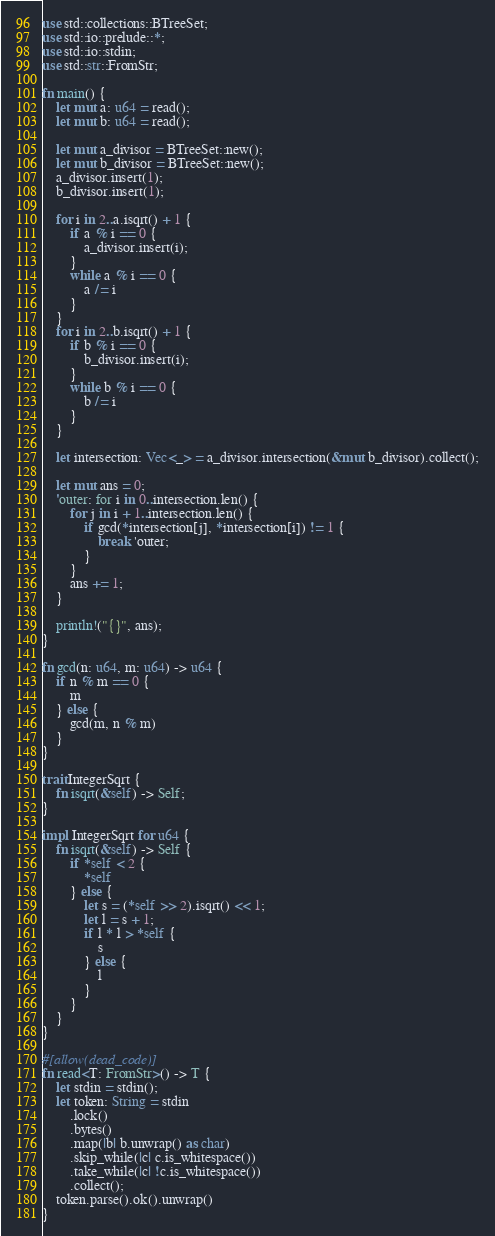<code> <loc_0><loc_0><loc_500><loc_500><_Rust_>use std::collections::BTreeSet;
use std::io::prelude::*;
use std::io::stdin;
use std::str::FromStr;

fn main() {
    let mut a: u64 = read();
    let mut b: u64 = read();

    let mut a_divisor = BTreeSet::new();
    let mut b_divisor = BTreeSet::new();
    a_divisor.insert(1);
    b_divisor.insert(1);

    for i in 2..a.isqrt() + 1 {
        if a % i == 0 {
            a_divisor.insert(i);
        }
        while a % i == 0 {
            a /= i
        }
    }
    for i in 2..b.isqrt() + 1 {
        if b % i == 0 {
            b_divisor.insert(i);
        }
        while b % i == 0 {
            b /= i
        }
    }

    let intersection: Vec<_> = a_divisor.intersection(&mut b_divisor).collect();

    let mut ans = 0;
    'outer: for i in 0..intersection.len() {
        for j in i + 1..intersection.len() {
            if gcd(*intersection[j], *intersection[i]) != 1 {
                break 'outer;
            }
        }
        ans += 1;
    }

    println!("{}", ans);
}

fn gcd(n: u64, m: u64) -> u64 {
    if n % m == 0 {
        m
    } else {
        gcd(m, n % m)
    }
}

trait IntegerSqrt {
    fn isqrt(&self) -> Self;
}

impl IntegerSqrt for u64 {
    fn isqrt(&self) -> Self {
        if *self < 2 {
            *self
        } else {
            let s = (*self >> 2).isqrt() << 1;
            let l = s + 1;
            if l * l > *self {
                s
            } else {
                l
            }
        }
    }
}

#[allow(dead_code)]
fn read<T: FromStr>() -> T {
    let stdin = stdin();
    let token: String = stdin
        .lock()
        .bytes()
        .map(|b| b.unwrap() as char)
        .skip_while(|c| c.is_whitespace())
        .take_while(|c| !c.is_whitespace())
        .collect();
    token.parse().ok().unwrap()
}
</code> 